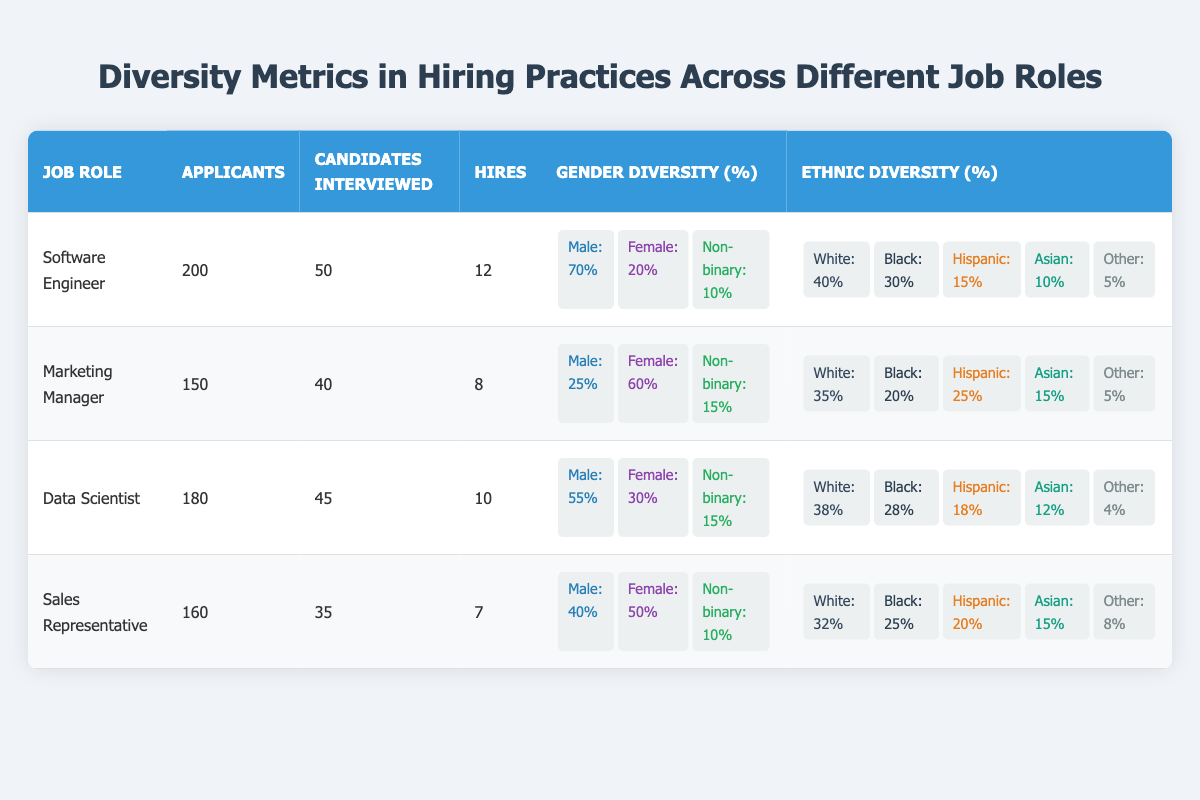What is the total number of applicants for the Marketing Manager role? The number of applicants for the Marketing Manager role is directly listed in the table, which states that there are 150 applicants.
Answer: 150 What percentage of hires for the Data Scientist role are female? The table shows that for the Data Scientist role, 30% of the applicants are female. This is derived from the gender diversity breakdown provided in the table.
Answer: 30% Are there more applicants for the Sales Representative role than the Software Engineer role? The number of applicants for the Sales Representative role is 160, while for the Software Engineer role, it is 200. Comparing these numbers shows that there are fewer applicants for Sales Representative.
Answer: No What is the average number of hires across all job roles? The total number of hires in each role are: Software Engineer (12), Marketing Manager (8), Data Scientist (10), and Sales Representative (7). Summing these hires gives 12 + 8 + 10 + 7 = 37. There are four job roles, so the average is 37/4 = 9.25.
Answer: 9.25 Which job role has the highest percentage of male applicants? The table indicates that the Software Engineer role has the highest percentage of male applicants at 70%. By comparing this percentage with other roles, it is clear that no other role exceeds this figure.
Answer: Software Engineer What percentage of candidates interviewed for the Marketing Manager role are male? For the Marketing Manager role, the percentage of male applicants is identified as 25%. This number comes from the gender diversity section and is calculated based on the total number of applicants.
Answer: 25% What is the difference in the percentage of White applicants between the Software Engineer and Sales Representative roles? The table lists the percentage of White applicants as 40% for the Software Engineer role and 32% for the Sales Representative role. The difference can be calculated as 40% - 32% = 8%.
Answer: 8% Do more than 50% of hires for the Data Scientist role come from non-binary candidates? The table specifies that 15% of the applicants for the Data Scientist role are non-binary. Since this percentage is less than 50%, it confirms that less than half of the hires are from non-binary candidates.
Answer: No What is the total percentage of Black candidates across all job roles? The Black applicant percentages in each role are: Software Engineer (30%), Marketing Manager (20%), Data Scientist (28%), and Sales Representative (25%). The total can be summed: 30% + 20% + 28% + 25% = 103%.
Answer: 103% 